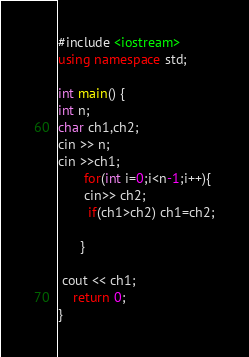<code> <loc_0><loc_0><loc_500><loc_500><_C++_>#include <iostream>
using namespace std;

int main() {
int n;
char ch1,ch2;
cin >> n;
cin >>ch1;
       for(int i=0;i<n-1;i++){
       cin>> ch2;    
        if(ch1>ch2) ch1=ch2;
   
      }

 cout << ch1;
	return 0;
}</code> 